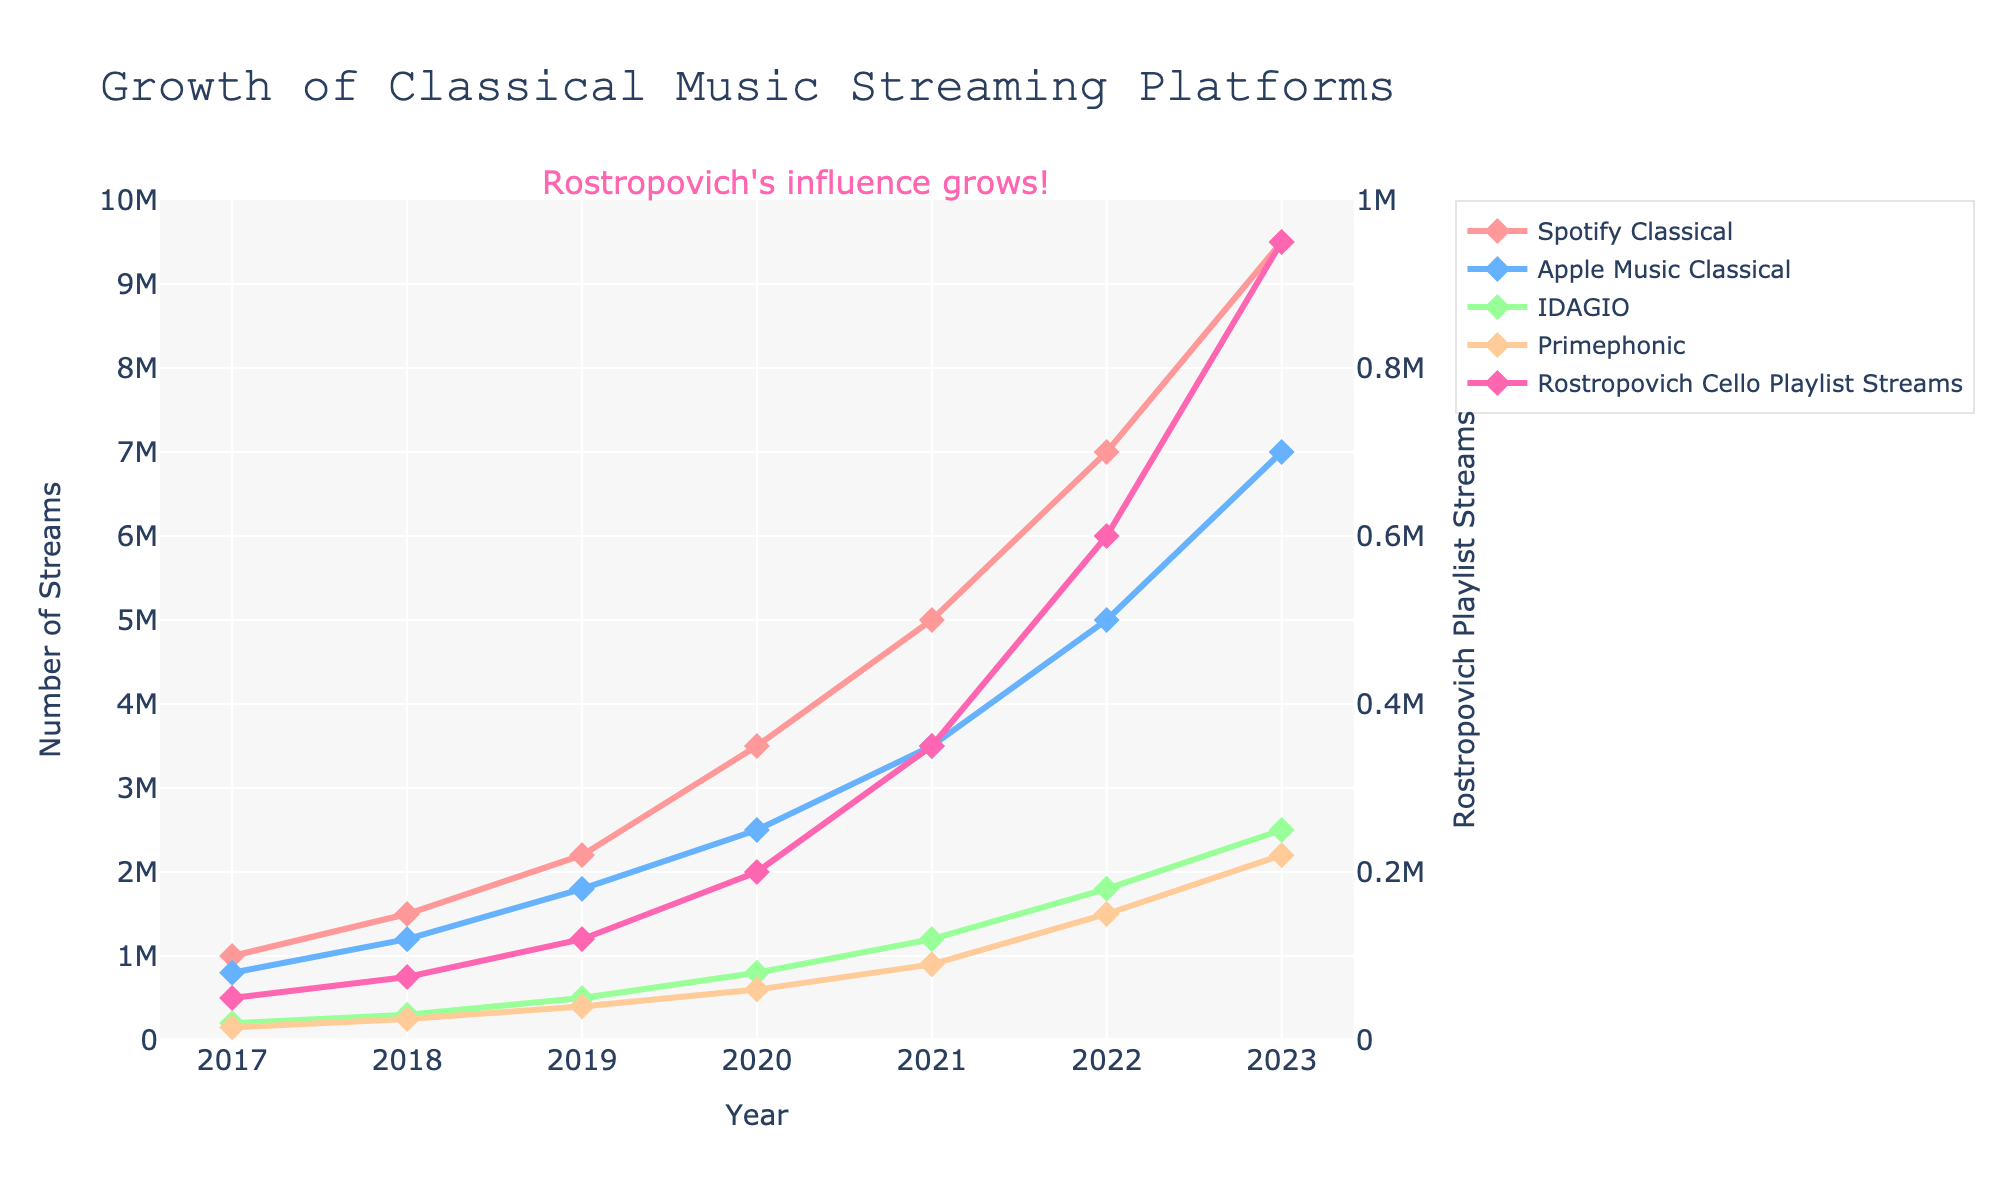What platform saw the greatest increase in streams from 2017 to 2023? To find the platform with the greatest increase, subtract the 2017 stream count from the 2023 stream count for all platforms. Spotify Classical: 9500000 - 1000000 = 8500000, Apple Music Classical: 7000000 - 800000 = 6200000, IDAGIO: 2500000 - 200000 = 2300000, Primephonic: 2200000 - 150000 = 2050000, Rostropovich Playlist Streams: 950000 - 50000 = 900000. Spotify Classical had the greatest increase.
Answer: Spotify Classical Which platform had the smallest number of streams in 2023? Look at the values for each platform in 2023. Spotify Classical: 9500000, Apple Music Classical: 7000000, IDAGIO: 2500000, Primephonic: 2200000, Rostropovich Playlist Streams: 950000. Rostropovich Playlist Streams had the smallest number of streams.
Answer: Rostropovich Cello Playlist Streams How does the growth trend of Rostropovich Cello Playlist Streams compare to Primephonic from 2017 to 2023? Compare the yearly growth for both. Rostropovich Cello Playlist Streams: 50000, 75000, 120000, 200000, 350000, 600000, 950000. Primephonic: 150000, 250000, 400000, 600000, 900000, 1500000, 2200000. Both show an increasing trend, but Primephonic has a steeper increase, especially after 2019.
Answer: Primephonic grew faster than Rostropovich Playlist Streams In which year did the Rostropovich Cello Playlist Streams exceed 100000? Look at the streams for each year: 2017: 50000, 2018: 75000, 2019: 120000, 2020: 200000, 2021: 350000, 2022: 600000, 2023: 950000. Rostropovich Cello Playlist Streams exceeded 100000 in 2019.
Answer: 2019 What is the total number of streams for IDAGIO from 2017 to 2023? Add the yearly streams for IDAGIO: 2017: 200000, 2018: 300000, 2019: 500000, 2020: 800000, 2021: 1200000, 2022: 1800000, 2023: 2500000. Total = 200000 + 300000 + 500000 + 800000 + 1200000 + 1800000 + 2500000 = 7300000.
Answer: 7300000 By how much did Spotify Classical streams increase from 2021 to 2022? Subtract the 2021 streams from the 2022 streams for Spotify Classical. 2022: 7000000, 2021: 5000000. Increase = 7000000 - 5000000 = 2000000.
Answer: 2000000 Which platform had the highest growth rate between 2021 and 2022? Calculate the growth rate for each platform between 2021 and 2022: Spotify Classical: (7000000 - 5000000)/5000000 = 0.4, Apple Music Classical: (5000000 - 3500000)/3500000 = 0.4286, IDAGIO: (1800000 - 1200000)/1200000 = 0.5, Primephonic: (1500000 - 900000)/900000 = 0.6667, Rostropovich Playlist Streams: (600000 - 350000)/350000 = 0.7143. Primephonic had the highest growth rate, but Rostropovich Playlist Streams also had a high growth rate.
Answer: Rostropovich Cello Playlist Streams What is the color used to represent Rostropovich Cello Playlist Streams in the plot? Identify the color used for the Rostropovich Cello Playlist Streams line and markers. The line and markers are pink.
Answer: Pink By how much did Apple Music Classical grow from 2019 to 2023? Subtract the 2019 streams from the 2023 streams for Apple Music Classical. 2023: 7000000, 2019: 1800000. Growth = 7000000 - 1800000 = 5200000.
Answer: 5200000 